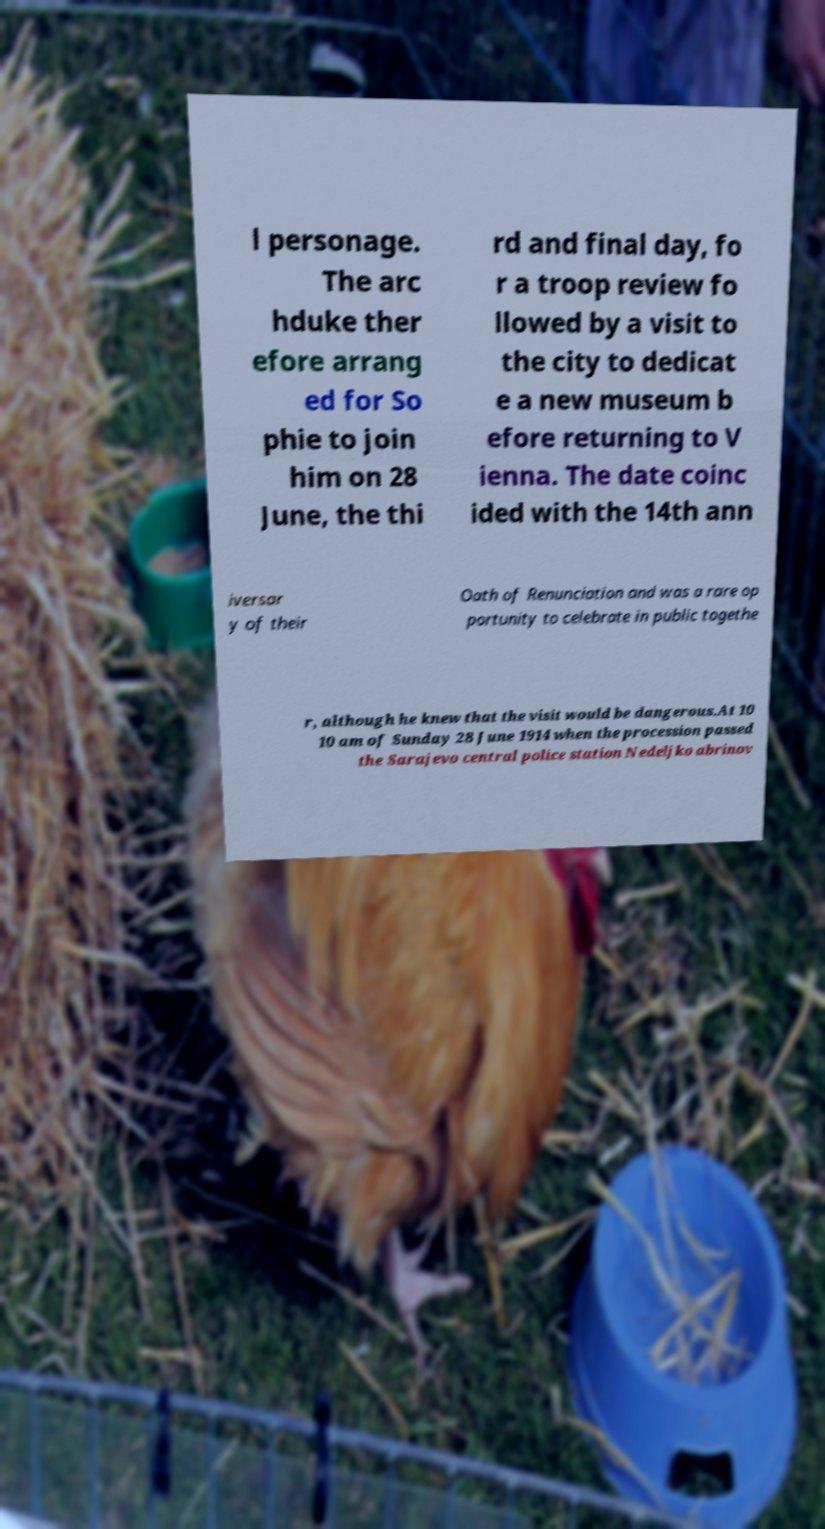Please identify and transcribe the text found in this image. l personage. The arc hduke ther efore arrang ed for So phie to join him on 28 June, the thi rd and final day, fo r a troop review fo llowed by a visit to the city to dedicat e a new museum b efore returning to V ienna. The date coinc ided with the 14th ann iversar y of their Oath of Renunciation and was a rare op portunity to celebrate in public togethe r, although he knew that the visit would be dangerous.At 10 10 am of Sunday 28 June 1914 when the procession passed the Sarajevo central police station Nedeljko abrinov 